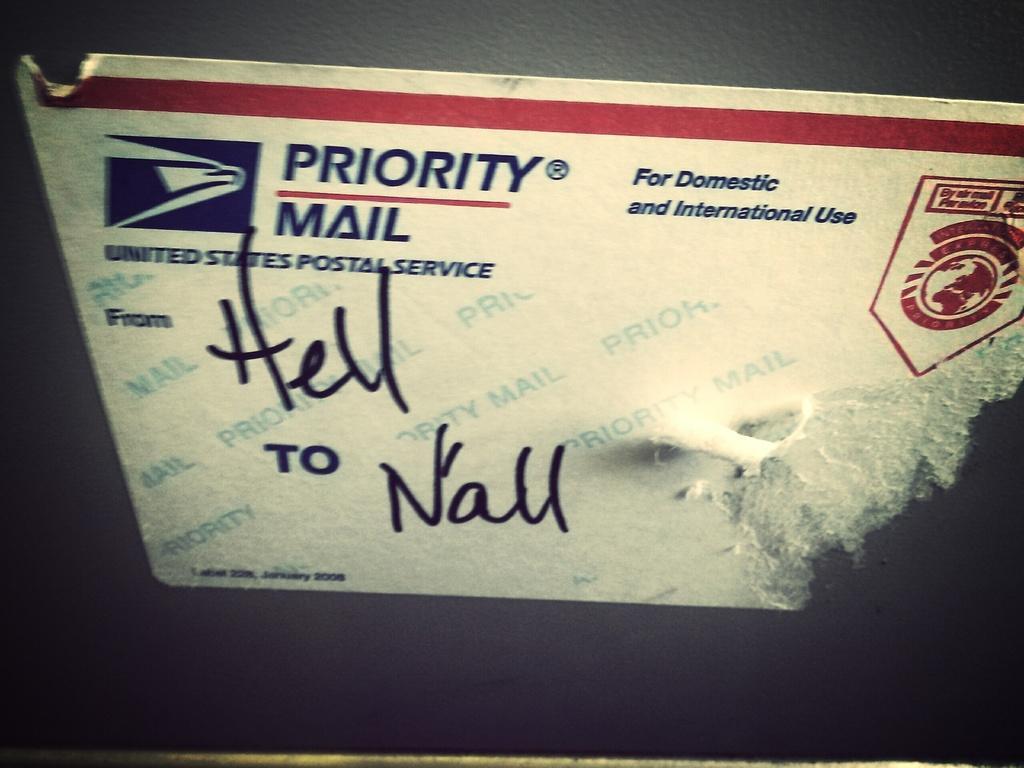Can you describe this image briefly? There is a sticker of postal service and the name of the sender and the receiver are mentioned on the sticker. 